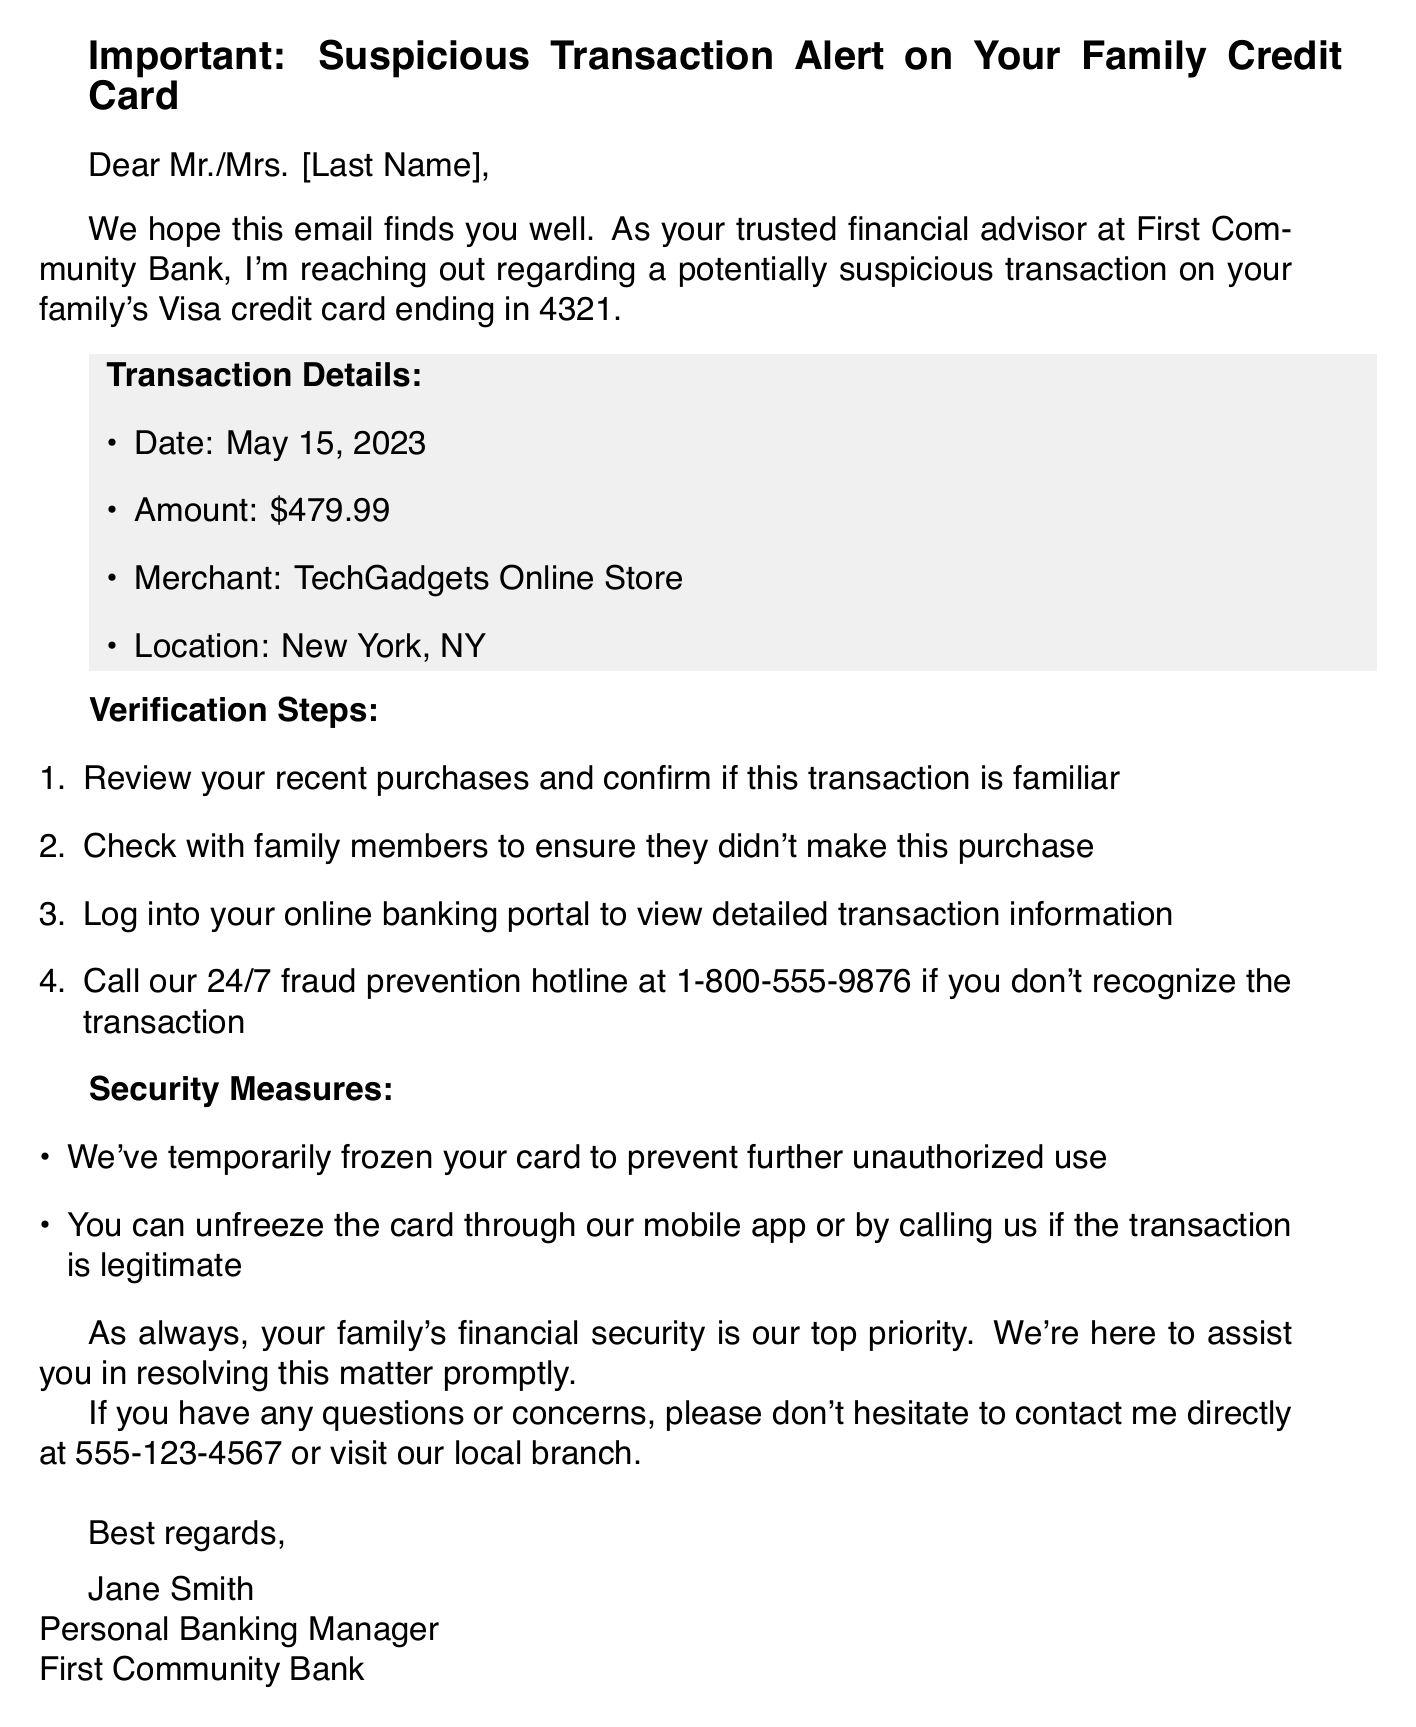What is the date of the suspicious transaction? The date of the suspicious transaction is clearly stated in the document under transaction details.
Answer: May 15, 2023 What is the transaction amount? The transaction amount is provided in the transaction details section of the document.
Answer: $479.99 Who should you contact if the transaction is not recognized? The document includes a clear instruction on whom to contact if the transaction is suspicious.
Answer: 24/7 fraud prevention hotline What is the name of the merchant involved in the transaction? The name of the merchant is mentioned in the transaction details, which is relevant information to identify the suspicious activity.
Answer: TechGadgets Online Store What action has been taken regarding the credit card? The document states the security measures that have been implemented concerning the credit card.
Answer: Temporarily frozen What is the purpose of the email? The overall intent of the email is clearly outlined, making it possible to infer the key message behind the communication.
Answer: Suspicious transaction alert How can you unfreeze the card? The email provides specific instructions on the process to unfreeze the card if the transaction is legitimate.
Answer: Mobile app or calling What should you do first to verify the transaction? The document lists the steps that should be undertaken to verify the suspicious transaction.
Answer: Review your recent purchases Who is the sender of the email? The sender's identity is mentioned at the end of the email, which is essential for identifying the source of the alert.
Answer: Jane Smith 